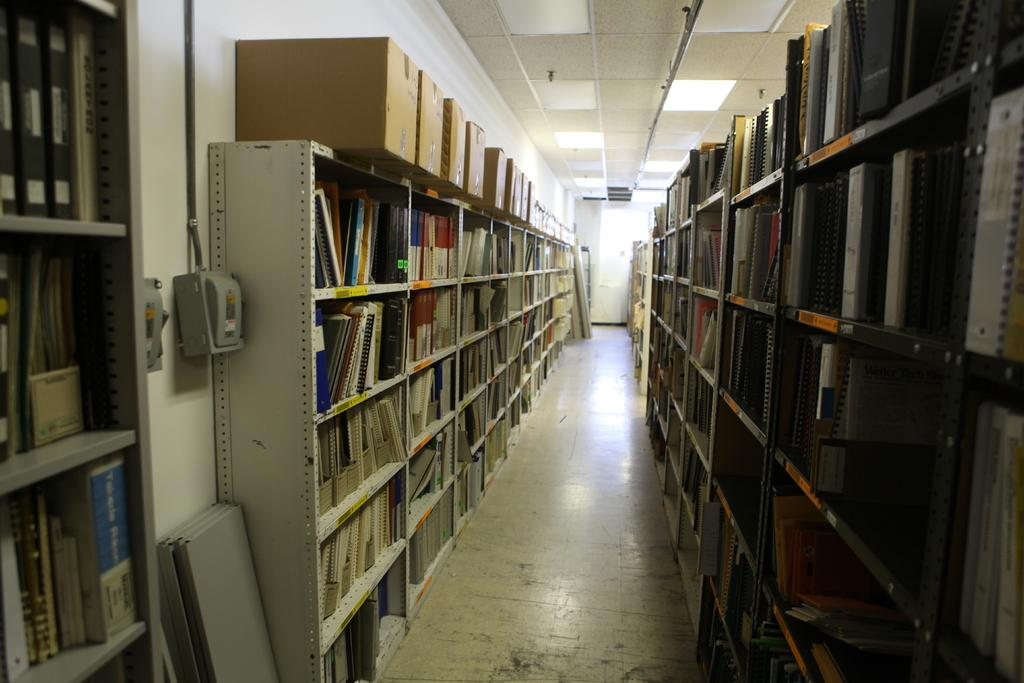What is stored in the cupboards in the image? There are books arranged in the racks of cupboards in the image. What type of flooring is present in the image? There are wooden planks on the floor in the image. What electronic devices can be seen in the image? Electric boards are visible in the image. What type of infrastructure is present in the image? Pipelines are present in the image. What type of containers are in the image? Cardboard cartons are in the image. What type of lighting is present in the image? There are electric lights on the roof in the image. What advice is given by the tank in the image? There is no tank present in the image, and therefore no advice can be given. How does the light from the tank affect the electric lights on the roof? There is no tank present in the image, so its light cannot affect the electric lights on the roof. 